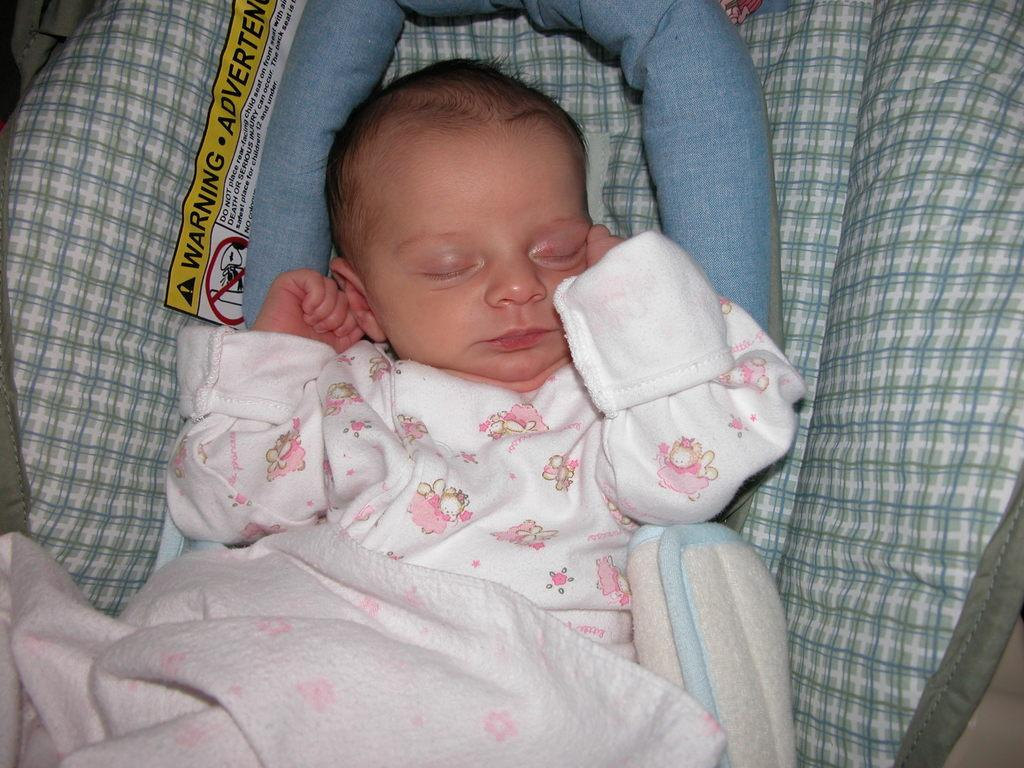What is the main subject of the image? The main subject of the image is a small baby. Where is the baby located in the image? The baby is sleeping in a kids bed. What is covering the baby in the image? A blanket is covering the baby. Can you identify any other objects in the image? Yes, there is a pillow in the image. How many people are in the crowd surrounding the baby's bed in the image? There is no crowd present in the image; it only shows a baby sleeping in a kids bed with a blanket and pillow. Is there a cave visible in the image? No, there is no cave present in the image. 